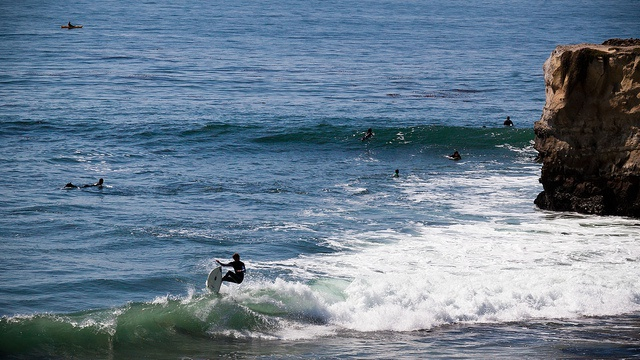Describe the objects in this image and their specific colors. I can see people in blue, black, gray, darkgray, and lightgray tones, surfboard in blue, purple, black, and darkgray tones, people in blue, black, and gray tones, people in blue, black, darkgray, and gray tones, and people in blue, black, gray, and darkblue tones in this image. 